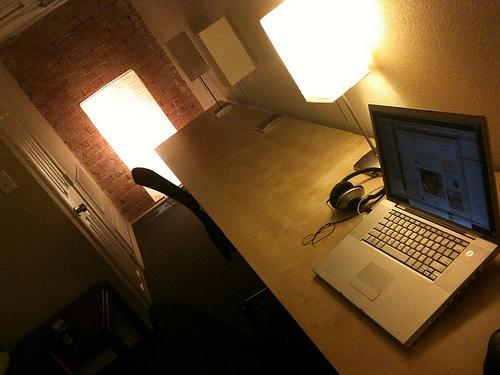List the primary objects visible in the picture and their relationship to each other. The image shows a table with a laptop, headphones, and lamps, a chair next to the desk, a brick wall with lights, and a closed door nearby. Identify the essential components of the image and describe their arrangement. The image features a table with a laptop, headphones, and lamps arranged on it, placed next to a chair, with a brick wall and a closed door in the background. Explain the central theme of the image and its significant elements. The image depicts a comfortable workspace area consisting of a table with an open laptop, headphones, and lamps, accompanied by a chair and set against a textured brick wall. Briefly narrate the focal point of the image and its surroundings. The image centers around a workspace setup consisting of a long table with an open laptop, headphones, and lamps, placed against a brick wall. In a single sentence, summarize the primary focus of the image. The main focus of the image is a thoughtfully arranged workspace with an open laptop, headphones, and table lamps against a brick wall. In one sentence, describe the general atmosphere conveyed by the image. The image presents a cozy workspace setup with a table showcasing a laptop, headphones, and lamps near a chair, against a brick wall backdrop. What is the primary subject of the image and the environment it is placed in? The main subject is a workspace setup featuring a table with a laptop, headphones, and lamps, placed against a brick wall alongside a chair. What is the scene depicted in the image and its central element? The scene portrays a cozy workspace arrangement with a table carrying a laptop, headphones, and lamps as the central element, against a brick wall backdrop. Mention the primary element in the scene and its function. A long tan table against the wall serves as a workspace with an open laptop, headphones, and table lamps on its surface. Briefly describe the main components of the image and the setting they are found in. The image features a table with an open laptop, headphones, and lamps in a room with a brick wall, a chair, and a closed door. 